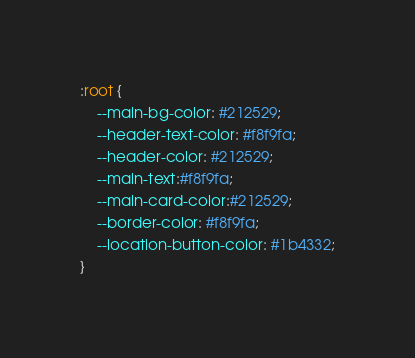<code> <loc_0><loc_0><loc_500><loc_500><_CSS_>:root {
    --main-bg-color: #212529;
    --header-text-color: #f8f9fa;
    --header-color: #212529;
    --main-text:#f8f9fa;
    --main-card-color:#212529;
    --border-color: #f8f9fa;
    --location-button-color: #1b4332;
}

</code> 